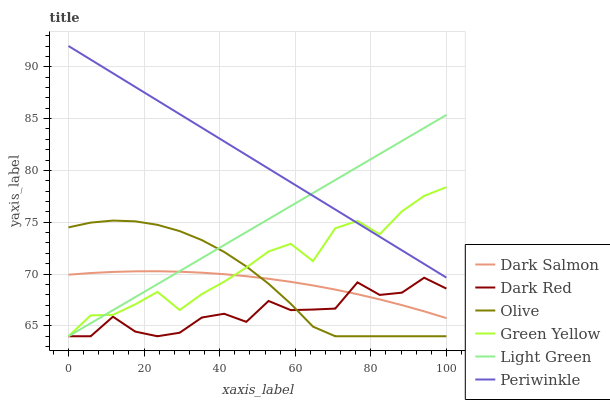Does Dark Red have the minimum area under the curve?
Answer yes or no. Yes. Does Periwinkle have the maximum area under the curve?
Answer yes or no. Yes. Does Dark Salmon have the minimum area under the curve?
Answer yes or no. No. Does Dark Salmon have the maximum area under the curve?
Answer yes or no. No. Is Light Green the smoothest?
Answer yes or no. Yes. Is Dark Red the roughest?
Answer yes or no. Yes. Is Dark Salmon the smoothest?
Answer yes or no. No. Is Dark Salmon the roughest?
Answer yes or no. No. Does Dark Red have the lowest value?
Answer yes or no. Yes. Does Dark Salmon have the lowest value?
Answer yes or no. No. Does Periwinkle have the highest value?
Answer yes or no. Yes. Does Dark Salmon have the highest value?
Answer yes or no. No. Is Dark Salmon less than Periwinkle?
Answer yes or no. Yes. Is Periwinkle greater than Dark Salmon?
Answer yes or no. Yes. Does Periwinkle intersect Green Yellow?
Answer yes or no. Yes. Is Periwinkle less than Green Yellow?
Answer yes or no. No. Is Periwinkle greater than Green Yellow?
Answer yes or no. No. Does Dark Salmon intersect Periwinkle?
Answer yes or no. No. 